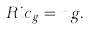<formula> <loc_0><loc_0><loc_500><loc_500>R i c _ { g } = n g .</formula> 